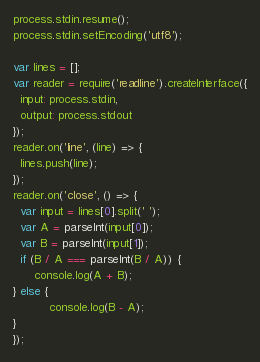<code> <loc_0><loc_0><loc_500><loc_500><_JavaScript_>process.stdin.resume();
process.stdin.setEncoding('utf8');

var lines = [];
var reader = require('readline').createInterface({
  input: process.stdin,
  output: process.stdout
});
reader.on('line', (line) => {
  lines.push(line);
});
reader.on('close', () => {
  var input = lines[0].split(' ');
  var A = parseInt(input[0]);
  var B = parseInt(input[1]);
  if (B / A === parseInt(B / A)) {
      console.log(A + B);
} else {
          console.log(B - A);
}
});</code> 